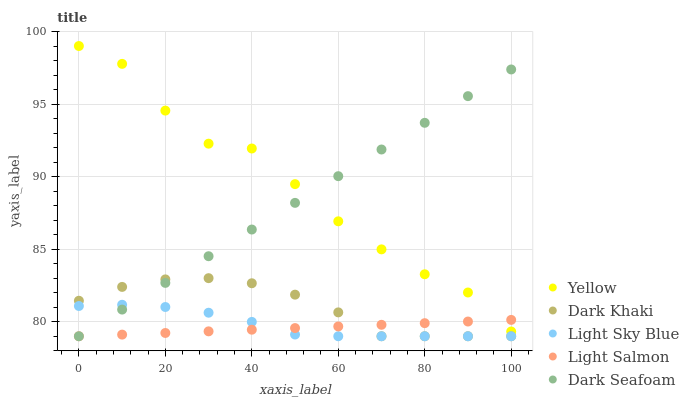Does Light Salmon have the minimum area under the curve?
Answer yes or no. Yes. Does Yellow have the maximum area under the curve?
Answer yes or no. Yes. Does Light Sky Blue have the minimum area under the curve?
Answer yes or no. No. Does Light Sky Blue have the maximum area under the curve?
Answer yes or no. No. Is Light Salmon the smoothest?
Answer yes or no. Yes. Is Yellow the roughest?
Answer yes or no. Yes. Is Light Sky Blue the smoothest?
Answer yes or no. No. Is Light Sky Blue the roughest?
Answer yes or no. No. Does Dark Khaki have the lowest value?
Answer yes or no. Yes. Does Yellow have the lowest value?
Answer yes or no. No. Does Yellow have the highest value?
Answer yes or no. Yes. Does Light Sky Blue have the highest value?
Answer yes or no. No. Is Dark Khaki less than Yellow?
Answer yes or no. Yes. Is Yellow greater than Dark Khaki?
Answer yes or no. Yes. Does Light Salmon intersect Dark Seafoam?
Answer yes or no. Yes. Is Light Salmon less than Dark Seafoam?
Answer yes or no. No. Is Light Salmon greater than Dark Seafoam?
Answer yes or no. No. Does Dark Khaki intersect Yellow?
Answer yes or no. No. 